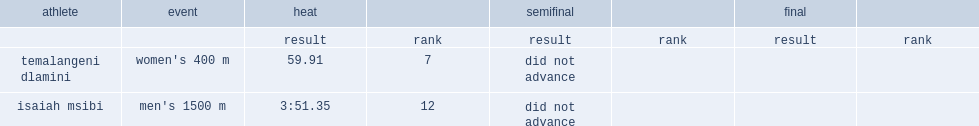In swaziland at the 2008 summer olympics, what was the result did temalangeni dlamini achieve a time in her heat, for seventh place? 59.91. 